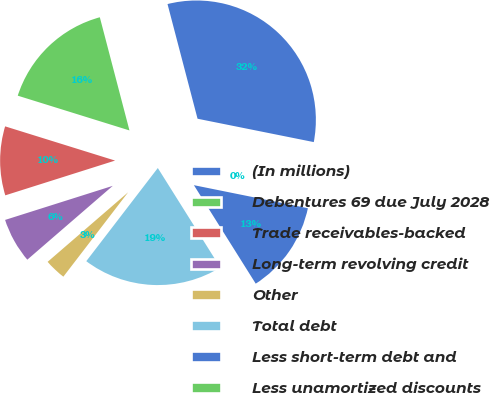Convert chart to OTSL. <chart><loc_0><loc_0><loc_500><loc_500><pie_chart><fcel>(In millions)<fcel>Debentures 69 due July 2028<fcel>Trade receivables-backed<fcel>Long-term revolving credit<fcel>Other<fcel>Total debt<fcel>Less short-term debt and<fcel>Less unamortized discounts<nl><fcel>32.23%<fcel>16.12%<fcel>9.68%<fcel>6.46%<fcel>3.24%<fcel>19.34%<fcel>12.9%<fcel>0.02%<nl></chart> 